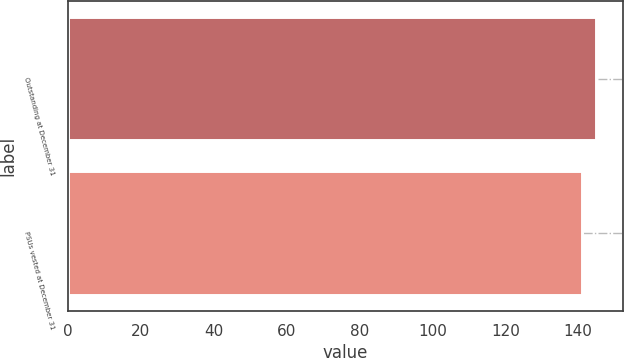<chart> <loc_0><loc_0><loc_500><loc_500><bar_chart><fcel>Outstanding at December 31<fcel>PSUs vested at December 31<nl><fcel>145<fcel>141<nl></chart> 